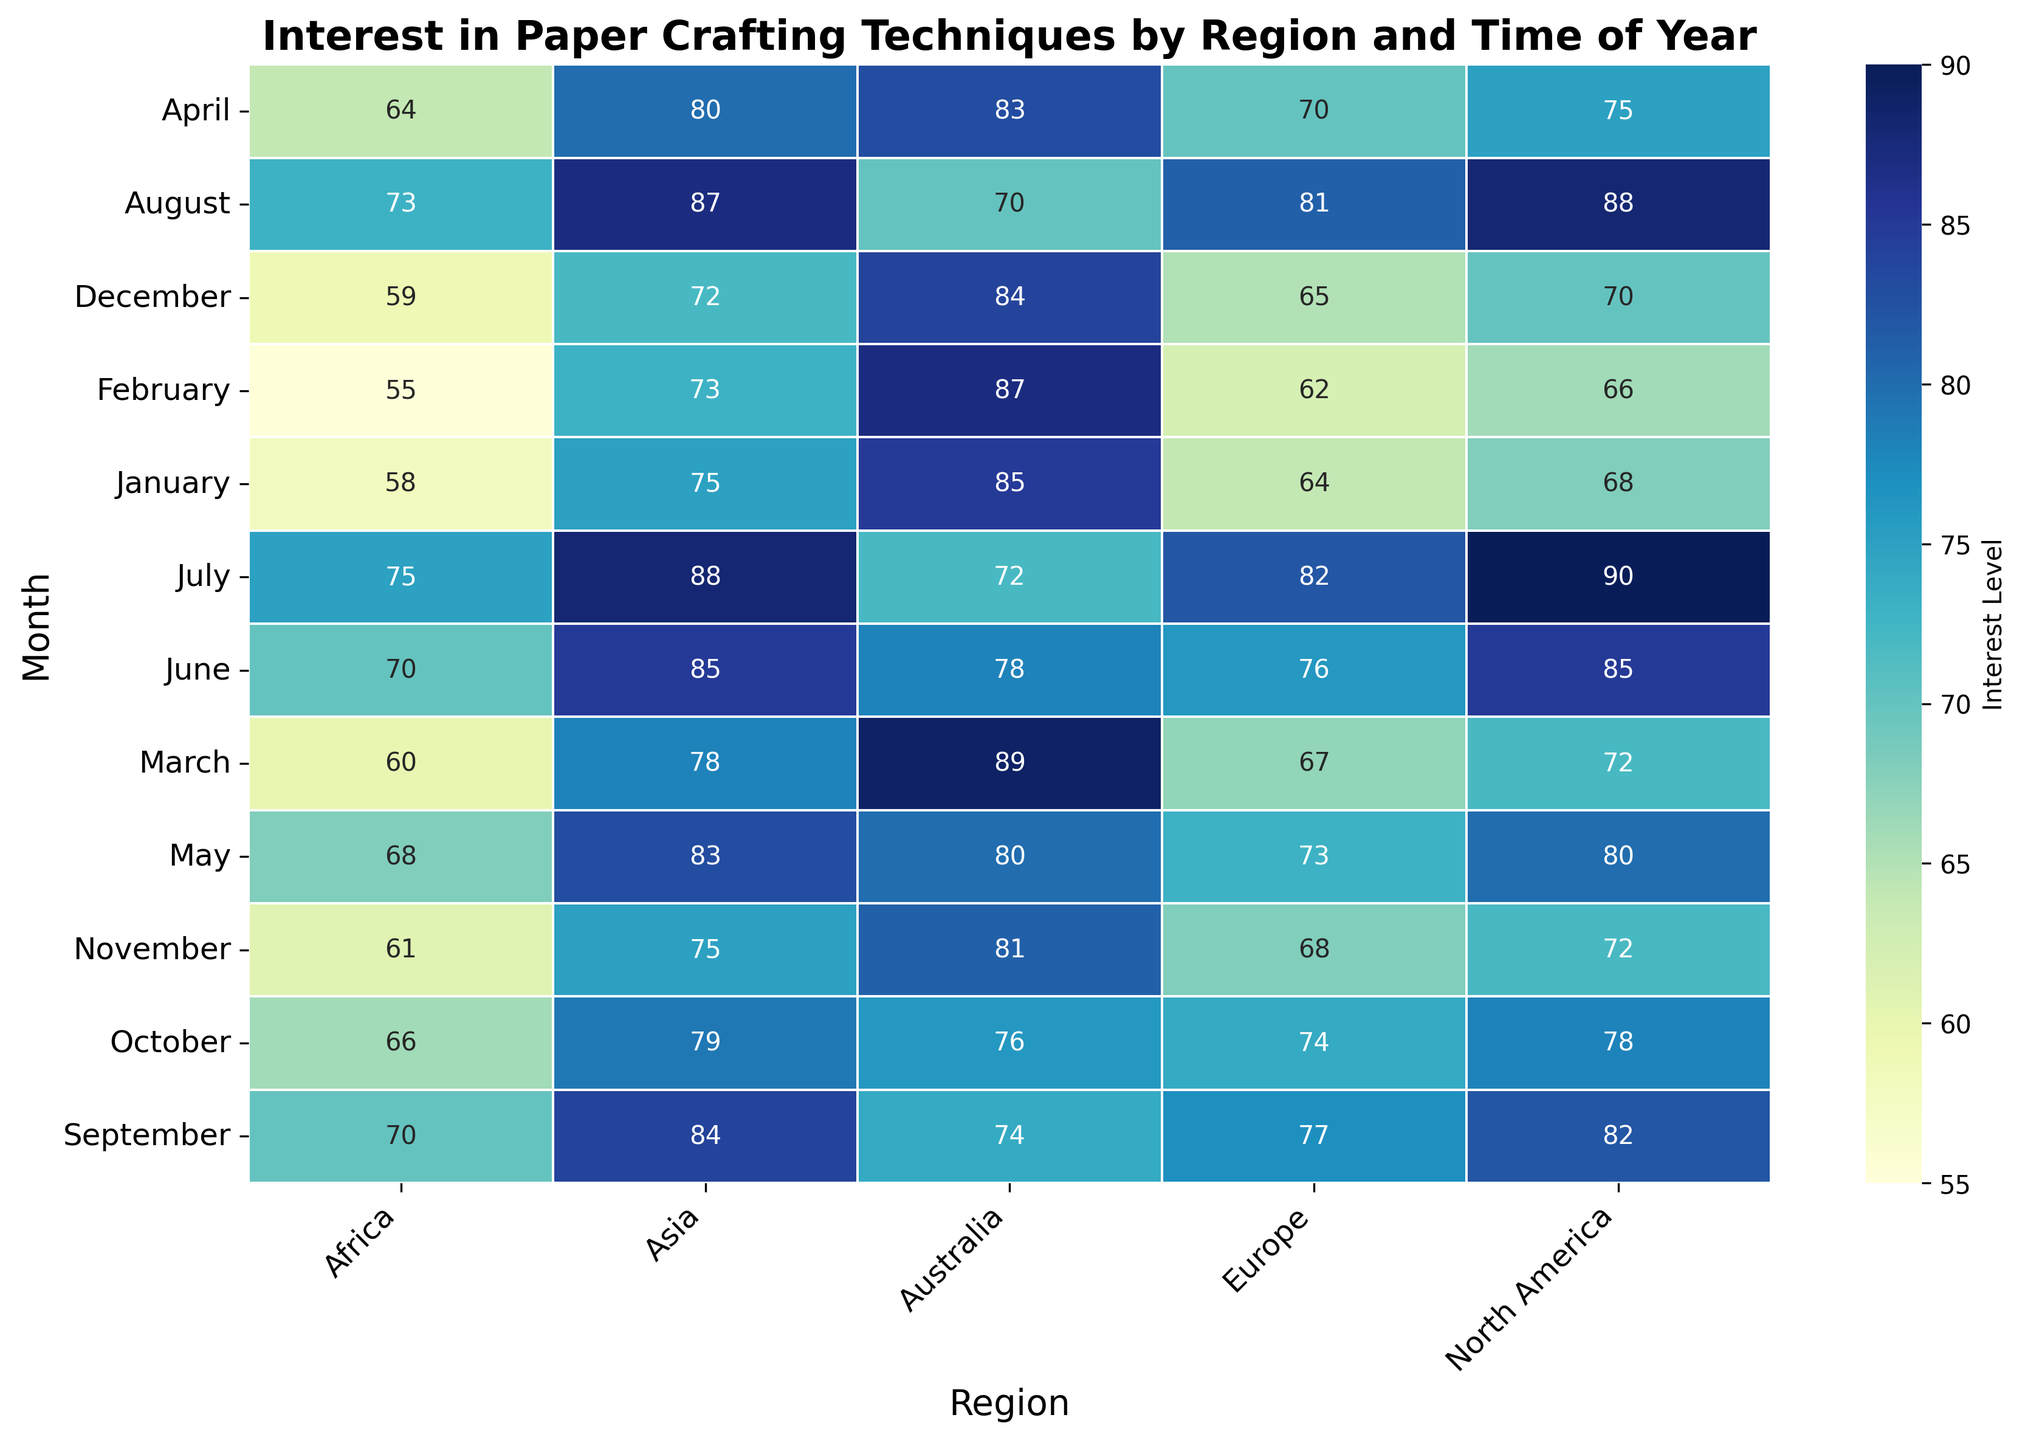How does the interest in paper crafting in North America in July compare to January? To compare them, look at the interest levels for North America in July and January. July has a value of 90, while January has a value of 68. Since 90 is greater than 68, the interest is higher in July.
Answer: The interest in July is higher Which region has the highest interest in October, and what is the value? To determine this, compare the interest levels for all regions in October. For North America, the value is 78; for Europe, it is 74; for Asia, it is 79; for Australia, it is 76; and for Africa, it is 66. Asia has the highest value at 79.
Answer: Asia, 79 What is the average interest level in paper crafting for Europe across the entire year? Calculate the monthly interest levels for Europe, and then find their average. The interest levels are 64, 62, 67, 70, 73, 76, 82, 81, 77, 74, 68, and 65. The sum is 859, and the average is 859/12 = 71.58.
Answer: 71.58 In which month does Asia see its lowest interest, and what is the value? Look through the interest levels for Asia month by month. The lowest value is found in December, with 72.
Answer: December, 72 Compare the trends in interest levels for Africa and Australia from June to September. Analyze the values for both regions from June to September. Africa's values are 70, 75, 73, 70, and Australia's values are 78, 72, 70, 74. Africa shows a rise and then a slight fall, while Australia shows an initial drop and then a rise.
Answer: Africa: rise then fall, Australia: fall then rise What is the difference in interest levels in June between North America and Africa? Subtract Africa's interest level in June (70) from North America's (85). The difference is 85 - 70.
Answer: 15 Which region sees the most significant increase from May to June? Compare the difference between May and June for each region. North America: +5 (80 to 85), Europe: +3 (73 to 76), Asia: +2 (83 to 85), Australia: -2 (78 to 76), Africa: +2 (68 to 70). North America has the largest increase of 5.
Answer: North America What is the range of interest levels for North America throughout the year? The range is found by subtracting the minimum value (66) from the maximum value (90) for North America.
Answer: 24 What is the sum of the interest levels for all regions in March? Add the values for March across all regions: North America (72) + Europe (67) + Asia (78) + Australia (89) + Africa (60). The sum is 366.
Answer: 366 